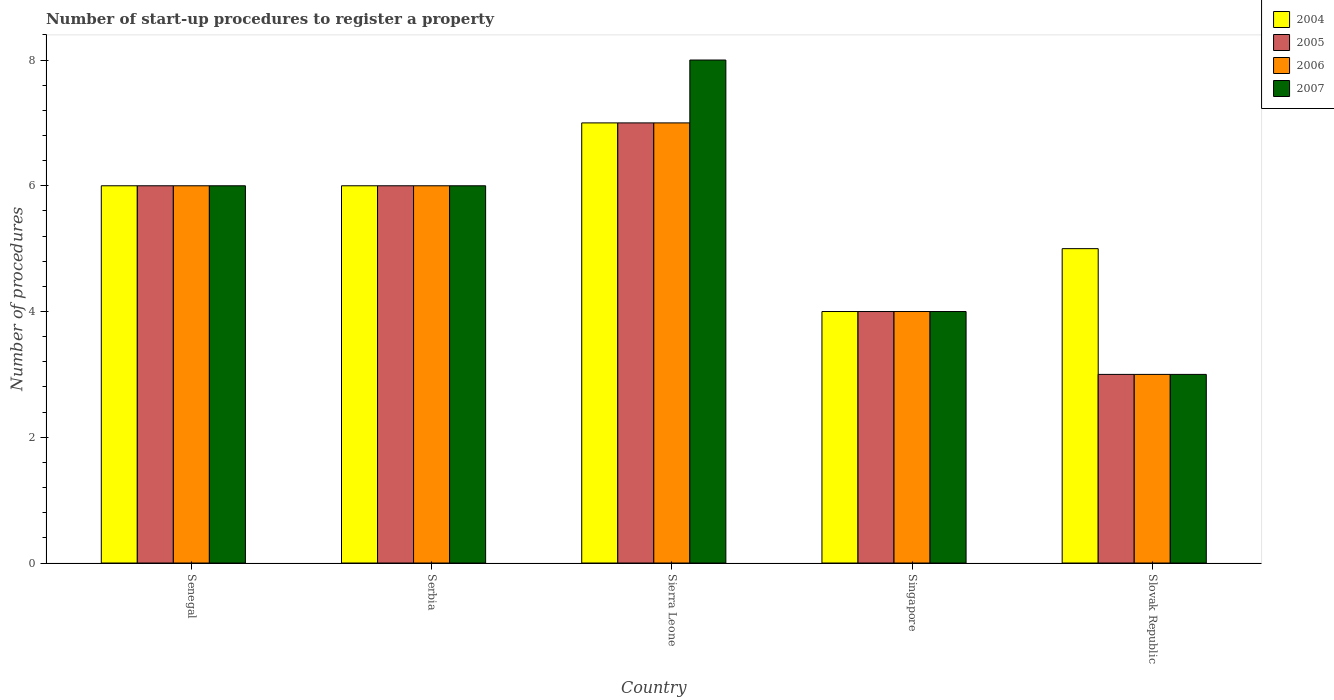How many groups of bars are there?
Your answer should be compact. 5. Are the number of bars per tick equal to the number of legend labels?
Your answer should be very brief. Yes. How many bars are there on the 1st tick from the left?
Your answer should be very brief. 4. What is the label of the 1st group of bars from the left?
Your answer should be very brief. Senegal. In how many cases, is the number of bars for a given country not equal to the number of legend labels?
Give a very brief answer. 0. In which country was the number of procedures required to register a property in 2006 maximum?
Your answer should be very brief. Sierra Leone. In which country was the number of procedures required to register a property in 2007 minimum?
Make the answer very short. Slovak Republic. What is the difference between the number of procedures required to register a property in 2005 in Serbia and that in Singapore?
Provide a short and direct response. 2. What is the difference between the number of procedures required to register a property in 2005 in Serbia and the number of procedures required to register a property in 2006 in Singapore?
Your response must be concise. 2. What is the difference between the number of procedures required to register a property of/in 2007 and number of procedures required to register a property of/in 2004 in Sierra Leone?
Provide a short and direct response. 1. In how many countries, is the number of procedures required to register a property in 2007 greater than 0.4?
Provide a short and direct response. 5. In how many countries, is the number of procedures required to register a property in 2005 greater than the average number of procedures required to register a property in 2005 taken over all countries?
Give a very brief answer. 3. Is the sum of the number of procedures required to register a property in 2004 in Senegal and Serbia greater than the maximum number of procedures required to register a property in 2007 across all countries?
Your answer should be very brief. Yes. Is it the case that in every country, the sum of the number of procedures required to register a property in 2006 and number of procedures required to register a property in 2004 is greater than the sum of number of procedures required to register a property in 2005 and number of procedures required to register a property in 2007?
Keep it short and to the point. No. What does the 1st bar from the right in Singapore represents?
Your answer should be compact. 2007. How many bars are there?
Provide a succinct answer. 20. How many countries are there in the graph?
Provide a short and direct response. 5. What is the difference between two consecutive major ticks on the Y-axis?
Provide a short and direct response. 2. Are the values on the major ticks of Y-axis written in scientific E-notation?
Keep it short and to the point. No. Does the graph contain any zero values?
Provide a short and direct response. No. Does the graph contain grids?
Give a very brief answer. No. What is the title of the graph?
Give a very brief answer. Number of start-up procedures to register a property. Does "2012" appear as one of the legend labels in the graph?
Your answer should be very brief. No. What is the label or title of the X-axis?
Ensure brevity in your answer.  Country. What is the label or title of the Y-axis?
Ensure brevity in your answer.  Number of procedures. What is the Number of procedures of 2004 in Senegal?
Keep it short and to the point. 6. What is the Number of procedures of 2005 in Senegal?
Your answer should be very brief. 6. What is the Number of procedures in 2005 in Serbia?
Offer a very short reply. 6. What is the Number of procedures in 2006 in Sierra Leone?
Offer a very short reply. 7. What is the Number of procedures of 2004 in Singapore?
Offer a very short reply. 4. What is the Number of procedures of 2004 in Slovak Republic?
Make the answer very short. 5. What is the Number of procedures of 2005 in Slovak Republic?
Provide a short and direct response. 3. What is the Number of procedures in 2006 in Slovak Republic?
Offer a terse response. 3. Across all countries, what is the maximum Number of procedures of 2005?
Give a very brief answer. 7. What is the total Number of procedures in 2005 in the graph?
Offer a very short reply. 26. What is the total Number of procedures in 2007 in the graph?
Make the answer very short. 27. What is the difference between the Number of procedures in 2004 in Senegal and that in Serbia?
Provide a short and direct response. 0. What is the difference between the Number of procedures in 2005 in Senegal and that in Serbia?
Provide a short and direct response. 0. What is the difference between the Number of procedures of 2006 in Senegal and that in Serbia?
Your answer should be compact. 0. What is the difference between the Number of procedures in 2004 in Senegal and that in Sierra Leone?
Your response must be concise. -1. What is the difference between the Number of procedures of 2006 in Senegal and that in Sierra Leone?
Keep it short and to the point. -1. What is the difference between the Number of procedures in 2007 in Senegal and that in Sierra Leone?
Ensure brevity in your answer.  -2. What is the difference between the Number of procedures of 2005 in Senegal and that in Singapore?
Provide a succinct answer. 2. What is the difference between the Number of procedures in 2006 in Senegal and that in Singapore?
Make the answer very short. 2. What is the difference between the Number of procedures of 2007 in Senegal and that in Singapore?
Your answer should be very brief. 2. What is the difference between the Number of procedures of 2004 in Senegal and that in Slovak Republic?
Your answer should be compact. 1. What is the difference between the Number of procedures of 2006 in Senegal and that in Slovak Republic?
Give a very brief answer. 3. What is the difference between the Number of procedures of 2007 in Senegal and that in Slovak Republic?
Keep it short and to the point. 3. What is the difference between the Number of procedures in 2007 in Serbia and that in Sierra Leone?
Keep it short and to the point. -2. What is the difference between the Number of procedures of 2004 in Serbia and that in Singapore?
Make the answer very short. 2. What is the difference between the Number of procedures in 2006 in Serbia and that in Singapore?
Your answer should be compact. 2. What is the difference between the Number of procedures of 2007 in Serbia and that in Singapore?
Offer a very short reply. 2. What is the difference between the Number of procedures of 2005 in Serbia and that in Slovak Republic?
Ensure brevity in your answer.  3. What is the difference between the Number of procedures of 2006 in Sierra Leone and that in Singapore?
Make the answer very short. 3. What is the difference between the Number of procedures of 2007 in Sierra Leone and that in Singapore?
Provide a succinct answer. 4. What is the difference between the Number of procedures of 2004 in Sierra Leone and that in Slovak Republic?
Ensure brevity in your answer.  2. What is the difference between the Number of procedures of 2005 in Sierra Leone and that in Slovak Republic?
Your response must be concise. 4. What is the difference between the Number of procedures of 2004 in Singapore and that in Slovak Republic?
Provide a succinct answer. -1. What is the difference between the Number of procedures of 2007 in Singapore and that in Slovak Republic?
Ensure brevity in your answer.  1. What is the difference between the Number of procedures in 2004 in Senegal and the Number of procedures in 2005 in Serbia?
Offer a terse response. 0. What is the difference between the Number of procedures of 2004 in Senegal and the Number of procedures of 2007 in Serbia?
Provide a short and direct response. 0. What is the difference between the Number of procedures of 2005 in Senegal and the Number of procedures of 2007 in Serbia?
Offer a very short reply. 0. What is the difference between the Number of procedures of 2006 in Senegal and the Number of procedures of 2007 in Serbia?
Your response must be concise. 0. What is the difference between the Number of procedures of 2004 in Senegal and the Number of procedures of 2005 in Sierra Leone?
Ensure brevity in your answer.  -1. What is the difference between the Number of procedures in 2004 in Senegal and the Number of procedures in 2006 in Sierra Leone?
Your answer should be compact. -1. What is the difference between the Number of procedures of 2004 in Senegal and the Number of procedures of 2007 in Sierra Leone?
Keep it short and to the point. -2. What is the difference between the Number of procedures in 2005 in Senegal and the Number of procedures in 2006 in Sierra Leone?
Provide a succinct answer. -1. What is the difference between the Number of procedures of 2004 in Senegal and the Number of procedures of 2005 in Singapore?
Your answer should be very brief. 2. What is the difference between the Number of procedures of 2004 in Senegal and the Number of procedures of 2007 in Singapore?
Keep it short and to the point. 2. What is the difference between the Number of procedures in 2006 in Senegal and the Number of procedures in 2007 in Singapore?
Your answer should be very brief. 2. What is the difference between the Number of procedures in 2004 in Senegal and the Number of procedures in 2005 in Slovak Republic?
Provide a short and direct response. 3. What is the difference between the Number of procedures of 2004 in Senegal and the Number of procedures of 2007 in Slovak Republic?
Make the answer very short. 3. What is the difference between the Number of procedures in 2006 in Senegal and the Number of procedures in 2007 in Slovak Republic?
Provide a short and direct response. 3. What is the difference between the Number of procedures of 2004 in Serbia and the Number of procedures of 2005 in Sierra Leone?
Your answer should be compact. -1. What is the difference between the Number of procedures in 2004 in Serbia and the Number of procedures in 2006 in Sierra Leone?
Your response must be concise. -1. What is the difference between the Number of procedures in 2005 in Serbia and the Number of procedures in 2007 in Sierra Leone?
Ensure brevity in your answer.  -2. What is the difference between the Number of procedures of 2006 in Serbia and the Number of procedures of 2007 in Sierra Leone?
Give a very brief answer. -2. What is the difference between the Number of procedures in 2004 in Serbia and the Number of procedures in 2007 in Singapore?
Your answer should be compact. 2. What is the difference between the Number of procedures in 2005 in Serbia and the Number of procedures in 2006 in Singapore?
Your response must be concise. 2. What is the difference between the Number of procedures in 2005 in Serbia and the Number of procedures in 2007 in Singapore?
Make the answer very short. 2. What is the difference between the Number of procedures in 2004 in Serbia and the Number of procedures in 2005 in Slovak Republic?
Your answer should be very brief. 3. What is the difference between the Number of procedures in 2004 in Serbia and the Number of procedures in 2006 in Slovak Republic?
Your answer should be compact. 3. What is the difference between the Number of procedures in 2004 in Serbia and the Number of procedures in 2007 in Slovak Republic?
Your answer should be compact. 3. What is the difference between the Number of procedures in 2004 in Sierra Leone and the Number of procedures in 2006 in Singapore?
Offer a terse response. 3. What is the difference between the Number of procedures of 2004 in Sierra Leone and the Number of procedures of 2007 in Singapore?
Provide a succinct answer. 3. What is the difference between the Number of procedures of 2005 in Sierra Leone and the Number of procedures of 2007 in Singapore?
Provide a short and direct response. 3. What is the difference between the Number of procedures in 2006 in Sierra Leone and the Number of procedures in 2007 in Singapore?
Ensure brevity in your answer.  3. What is the difference between the Number of procedures in 2004 in Sierra Leone and the Number of procedures in 2006 in Slovak Republic?
Ensure brevity in your answer.  4. What is the difference between the Number of procedures of 2004 in Singapore and the Number of procedures of 2007 in Slovak Republic?
Provide a succinct answer. 1. What is the difference between the Number of procedures in 2005 in Singapore and the Number of procedures in 2007 in Slovak Republic?
Keep it short and to the point. 1. What is the average Number of procedures of 2005 per country?
Offer a terse response. 5.2. What is the average Number of procedures of 2006 per country?
Provide a succinct answer. 5.2. What is the difference between the Number of procedures in 2004 and Number of procedures in 2005 in Senegal?
Offer a terse response. 0. What is the difference between the Number of procedures of 2004 and Number of procedures of 2007 in Senegal?
Provide a short and direct response. 0. What is the difference between the Number of procedures of 2005 and Number of procedures of 2006 in Senegal?
Your answer should be compact. 0. What is the difference between the Number of procedures of 2006 and Number of procedures of 2007 in Senegal?
Offer a terse response. 0. What is the difference between the Number of procedures in 2004 and Number of procedures in 2006 in Serbia?
Provide a short and direct response. 0. What is the difference between the Number of procedures of 2004 and Number of procedures of 2007 in Serbia?
Offer a terse response. 0. What is the difference between the Number of procedures of 2005 and Number of procedures of 2007 in Serbia?
Your answer should be compact. 0. What is the difference between the Number of procedures in 2004 and Number of procedures in 2007 in Sierra Leone?
Make the answer very short. -1. What is the difference between the Number of procedures in 2005 and Number of procedures in 2006 in Sierra Leone?
Your response must be concise. 0. What is the difference between the Number of procedures of 2005 and Number of procedures of 2007 in Sierra Leone?
Give a very brief answer. -1. What is the difference between the Number of procedures of 2006 and Number of procedures of 2007 in Sierra Leone?
Your answer should be compact. -1. What is the difference between the Number of procedures of 2004 and Number of procedures of 2005 in Singapore?
Give a very brief answer. 0. What is the difference between the Number of procedures in 2005 and Number of procedures in 2006 in Singapore?
Make the answer very short. 0. What is the difference between the Number of procedures of 2006 and Number of procedures of 2007 in Singapore?
Give a very brief answer. 0. What is the difference between the Number of procedures in 2004 and Number of procedures in 2005 in Slovak Republic?
Give a very brief answer. 2. What is the difference between the Number of procedures of 2005 and Number of procedures of 2006 in Slovak Republic?
Ensure brevity in your answer.  0. What is the ratio of the Number of procedures of 2004 in Senegal to that in Serbia?
Give a very brief answer. 1. What is the ratio of the Number of procedures of 2005 in Senegal to that in Serbia?
Ensure brevity in your answer.  1. What is the ratio of the Number of procedures of 2007 in Senegal to that in Serbia?
Make the answer very short. 1. What is the ratio of the Number of procedures of 2005 in Senegal to that in Sierra Leone?
Ensure brevity in your answer.  0.86. What is the ratio of the Number of procedures of 2007 in Senegal to that in Sierra Leone?
Make the answer very short. 0.75. What is the ratio of the Number of procedures of 2004 in Senegal to that in Singapore?
Provide a short and direct response. 1.5. What is the ratio of the Number of procedures in 2007 in Senegal to that in Singapore?
Your answer should be compact. 1.5. What is the ratio of the Number of procedures of 2004 in Senegal to that in Slovak Republic?
Offer a very short reply. 1.2. What is the ratio of the Number of procedures of 2007 in Senegal to that in Slovak Republic?
Keep it short and to the point. 2. What is the ratio of the Number of procedures in 2004 in Serbia to that in Sierra Leone?
Keep it short and to the point. 0.86. What is the ratio of the Number of procedures of 2006 in Serbia to that in Sierra Leone?
Make the answer very short. 0.86. What is the ratio of the Number of procedures in 2007 in Serbia to that in Sierra Leone?
Offer a very short reply. 0.75. What is the ratio of the Number of procedures of 2004 in Serbia to that in Singapore?
Offer a very short reply. 1.5. What is the ratio of the Number of procedures of 2005 in Serbia to that in Singapore?
Your answer should be very brief. 1.5. What is the ratio of the Number of procedures in 2004 in Serbia to that in Slovak Republic?
Give a very brief answer. 1.2. What is the ratio of the Number of procedures in 2005 in Serbia to that in Slovak Republic?
Your answer should be compact. 2. What is the ratio of the Number of procedures of 2006 in Sierra Leone to that in Singapore?
Provide a short and direct response. 1.75. What is the ratio of the Number of procedures in 2007 in Sierra Leone to that in Singapore?
Ensure brevity in your answer.  2. What is the ratio of the Number of procedures in 2004 in Sierra Leone to that in Slovak Republic?
Offer a terse response. 1.4. What is the ratio of the Number of procedures of 2005 in Sierra Leone to that in Slovak Republic?
Keep it short and to the point. 2.33. What is the ratio of the Number of procedures of 2006 in Sierra Leone to that in Slovak Republic?
Make the answer very short. 2.33. What is the ratio of the Number of procedures in 2007 in Sierra Leone to that in Slovak Republic?
Provide a short and direct response. 2.67. What is the ratio of the Number of procedures of 2005 in Singapore to that in Slovak Republic?
Your response must be concise. 1.33. What is the difference between the highest and the second highest Number of procedures in 2005?
Offer a very short reply. 1. What is the difference between the highest and the lowest Number of procedures of 2007?
Your answer should be very brief. 5. 